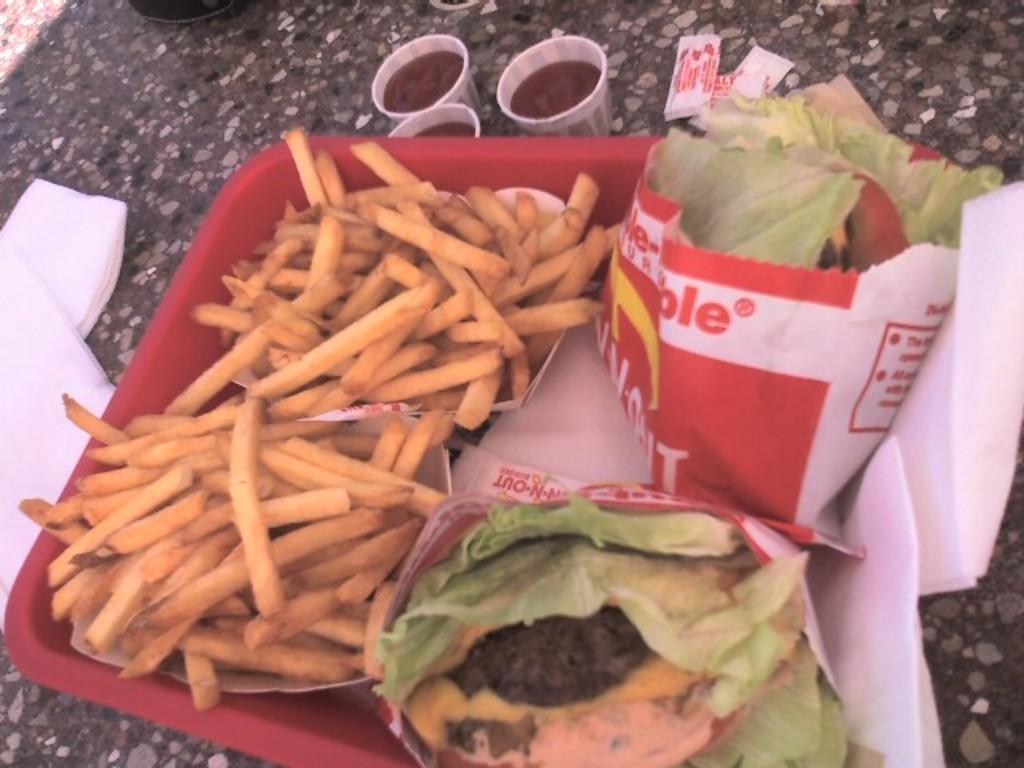Could you give a brief overview of what you see in this image? In this picture we can observe some fries placed in the red color plate and there is some food along with some tissues in the plate. There are three cups placed on the table. In the left side we can observe tissues. 